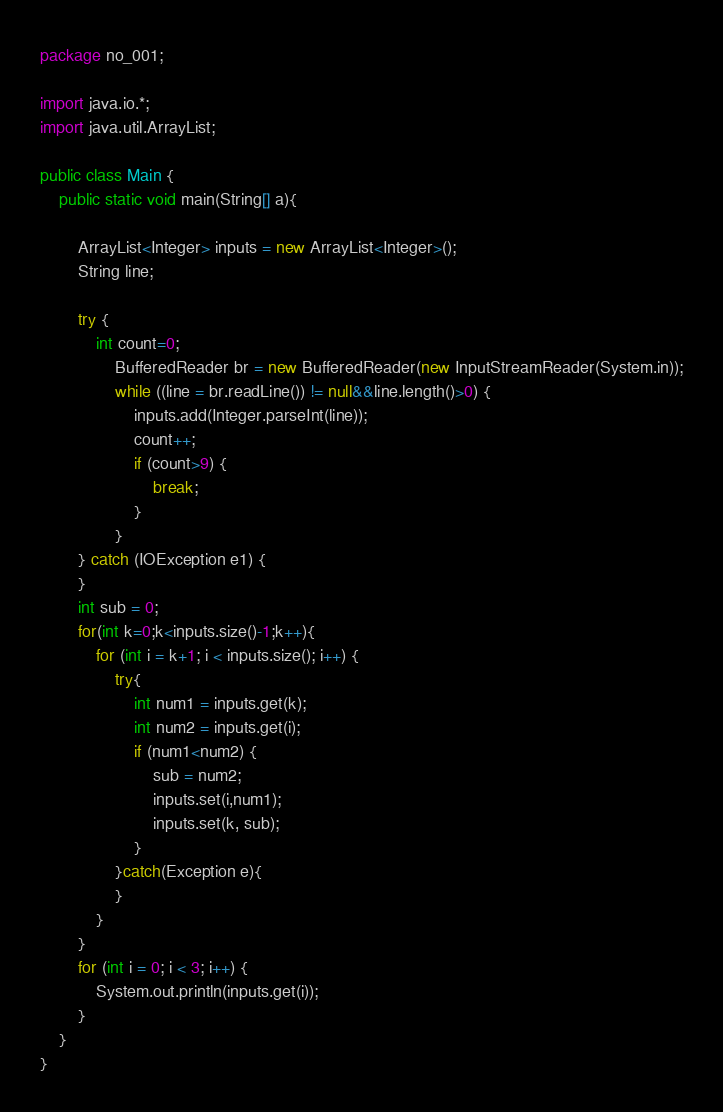Convert code to text. <code><loc_0><loc_0><loc_500><loc_500><_Java_>package no_001;

import java.io.*;
import java.util.ArrayList;

public class Main {
	public static void main(String[] a){

		ArrayList<Integer> inputs = new ArrayList<Integer>(); 
		String line;

		try {
			int count=0;
				BufferedReader br = new BufferedReader(new InputStreamReader(System.in));
				while ((line = br.readLine()) != null&&line.length()>0) {
					inputs.add(Integer.parseInt(line));
					count++;
					if (count>9) {
						break;
					}
				}
		} catch (IOException e1) {
		}
		int sub = 0;
		for(int k=0;k<inputs.size()-1;k++){
			for (int i = k+1; i < inputs.size(); i++) {
				try{
					int num1 = inputs.get(k);
					int num2 = inputs.get(i);
					if (num1<num2) {
						sub = num2;
						inputs.set(i,num1);
						inputs.set(k, sub);
					}
				}catch(Exception e){
				}
			}
		}
		for (int i = 0; i < 3; i++) {
			System.out.println(inputs.get(i));
		}
	}
}</code> 